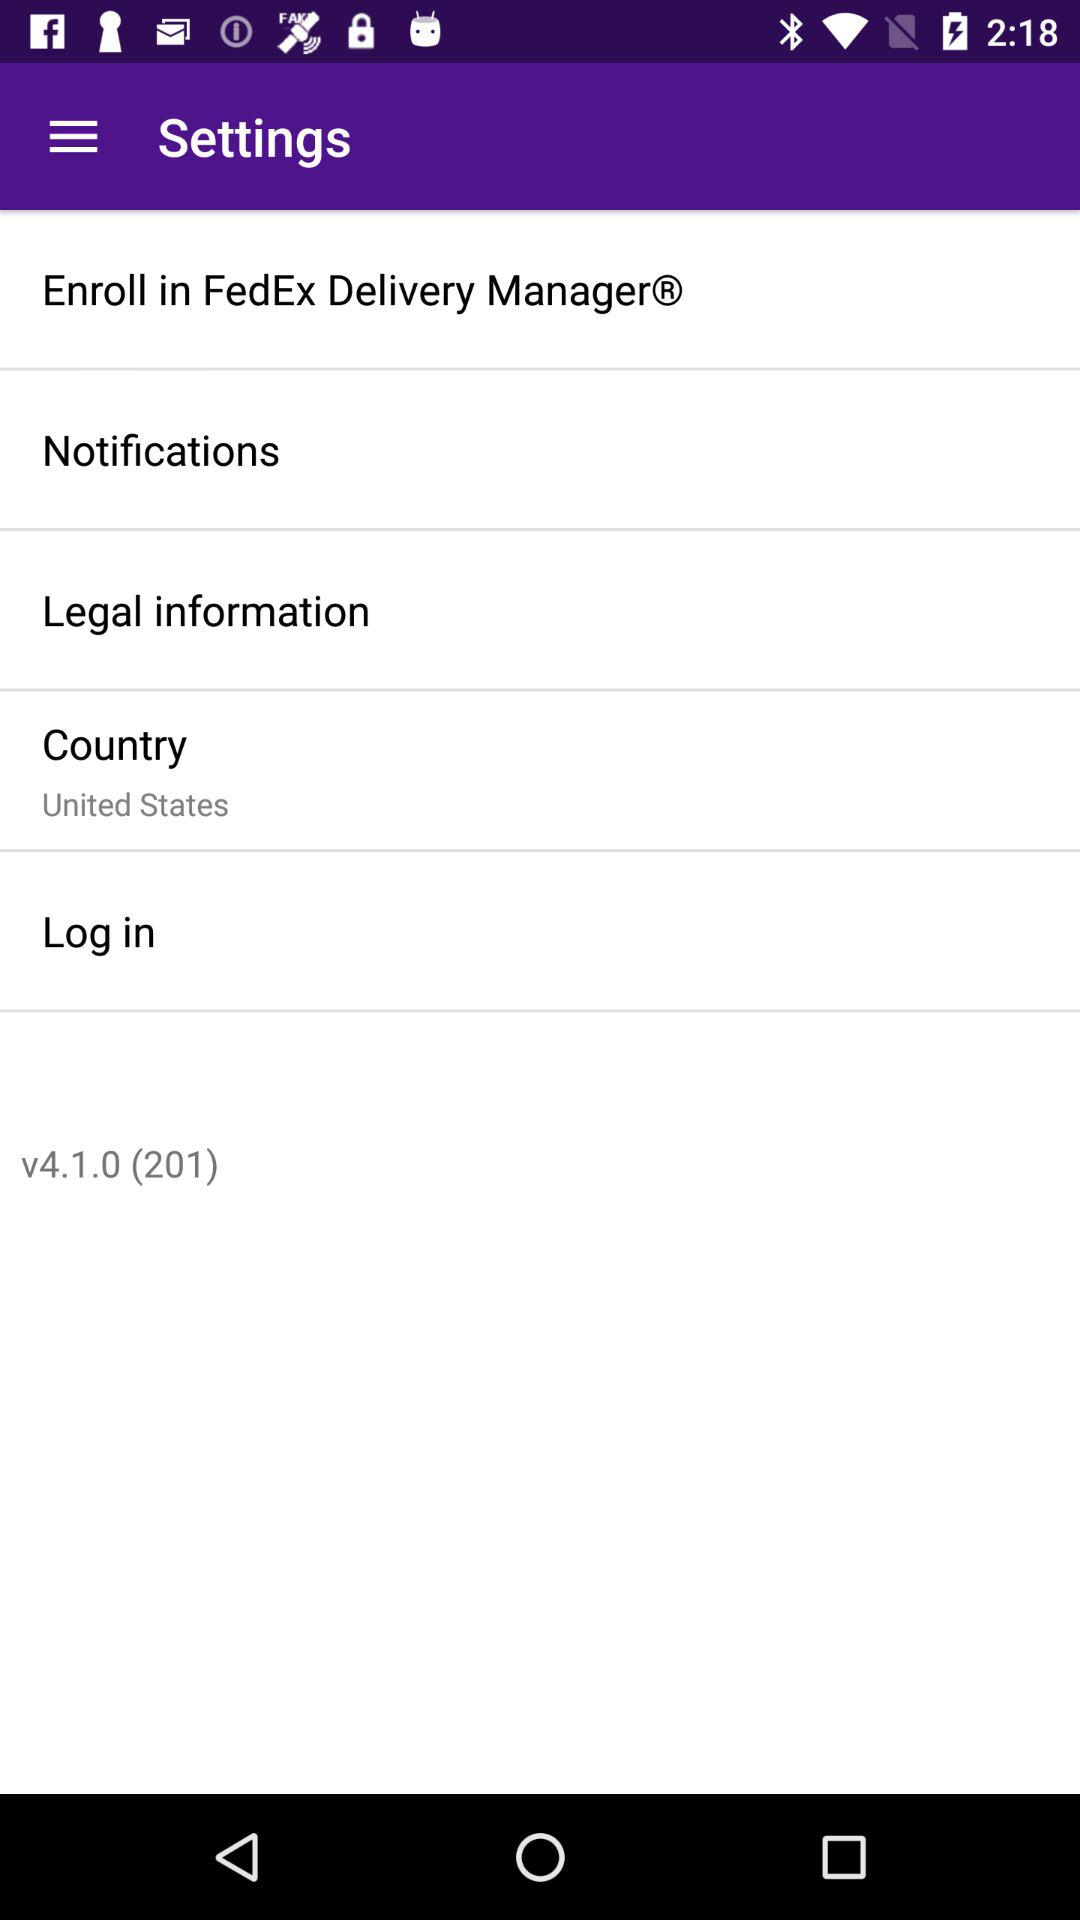What country is it? The country is the United States. 